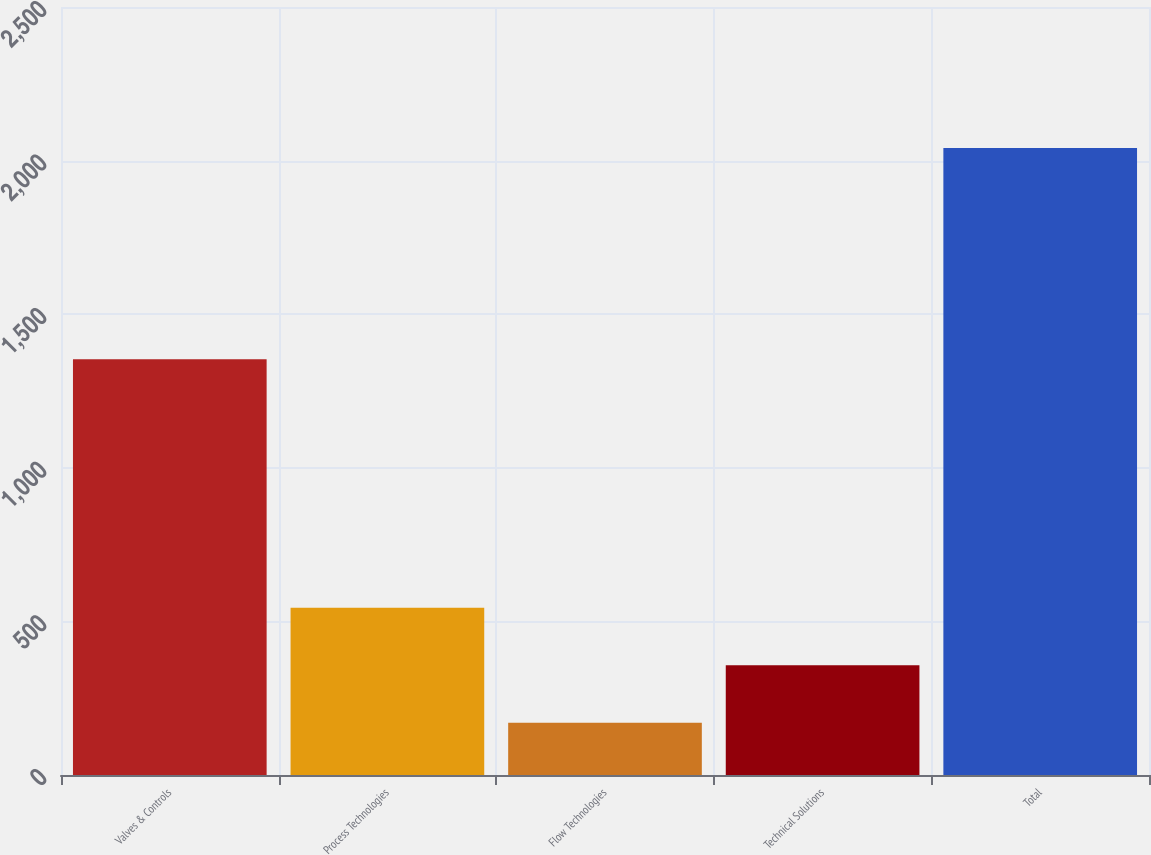<chart> <loc_0><loc_0><loc_500><loc_500><bar_chart><fcel>Valves & Controls<fcel>Process Technologies<fcel>Flow Technologies<fcel>Technical Solutions<fcel>Total<nl><fcel>1353.2<fcel>544.32<fcel>170.2<fcel>357.26<fcel>2040.8<nl></chart> 